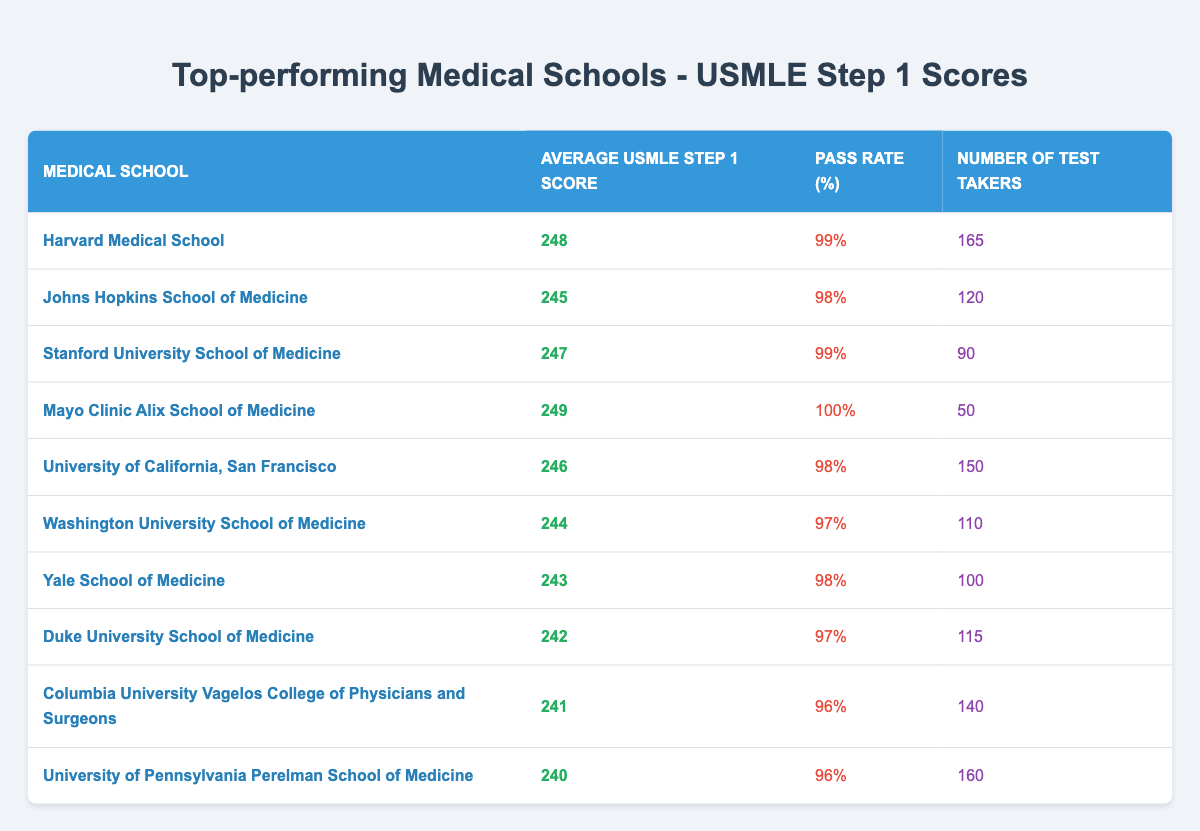What is the average USMLE Step 1 score for Harvard Medical School? According to the table, Harvard Medical School's average USMLE Step 1 score is directly listed under the Average USMLE Step 1 Score column as 248.
Answer: 248 What is the pass rate for Yale School of Medicine? The pass rate for Yale School of Medicine is provided in the Pass Rate (%) column, which states it is 98%.
Answer: 98% Which medical school has the highest number of test takers? By comparing the Number of Test Takers column, the highest number is 165, which corresponds to Harvard Medical School.
Answer: Harvard Medical School What is the difference in average scores between the Mayo Clinic Alix School of Medicine and the University of Pennsylvania Perelman School of Medicine? The average score for Mayo Clinic Alix School of Medicine is 249, and for University of Pennsylvania Perelman School of Medicine it is 240. The difference is 249 - 240 = 9.
Answer: 9 Is it true that Columbia University Vagelos College of Physicians and Surgeons has a pass rate of 96%? The Pass Rate (%) column shows that indeed, Columbia University Vagelos College of Physicians and Surgeons has a pass rate listed as 96%.
Answer: Yes Which medical school has a score that is at least 240 but not higher than 245? Looking at the Average USMLE Step 1 Score column, Washington University School of Medicine (244) and Columbia University Vagelos College of Physicians and Surgeons (241) fit these criteria.
Answer: Washington University School of Medicine, Columbia University Vagelos College of Physicians and Surgeons What is the average pass rate of the top four medical schools based on USMLE Step 1 scores? The pass rates for the top four schools (Mayo Clinic Alix School of Medicine, Harvard Medical School, Stanford University School of Medicine, Johns Hopkins School of Medicine) are 100%, 99%, 99%, and 98% respectively. The average is (100 + 99 + 99 + 98) / 4 = 99.
Answer: 99 How many medical schools listed have a pass rate greater than 97%? The schools with a pass rate greater than 97% are Harvard Medical School, Mayo Clinic Alix School of Medicine, Stanford University School of Medicine, Johns Hopkins School of Medicine, and Yale School of Medicine, totaling 5 schools.
Answer: 5 What is the total number of test takers across all medical schools listed? To find the total number of test takers, add the numbers in the Number of Test Takers column: 165 + 120 + 90 + 50 + 150 + 110 + 100 + 115 + 140 + 160 = 1,290.
Answer: 1290 